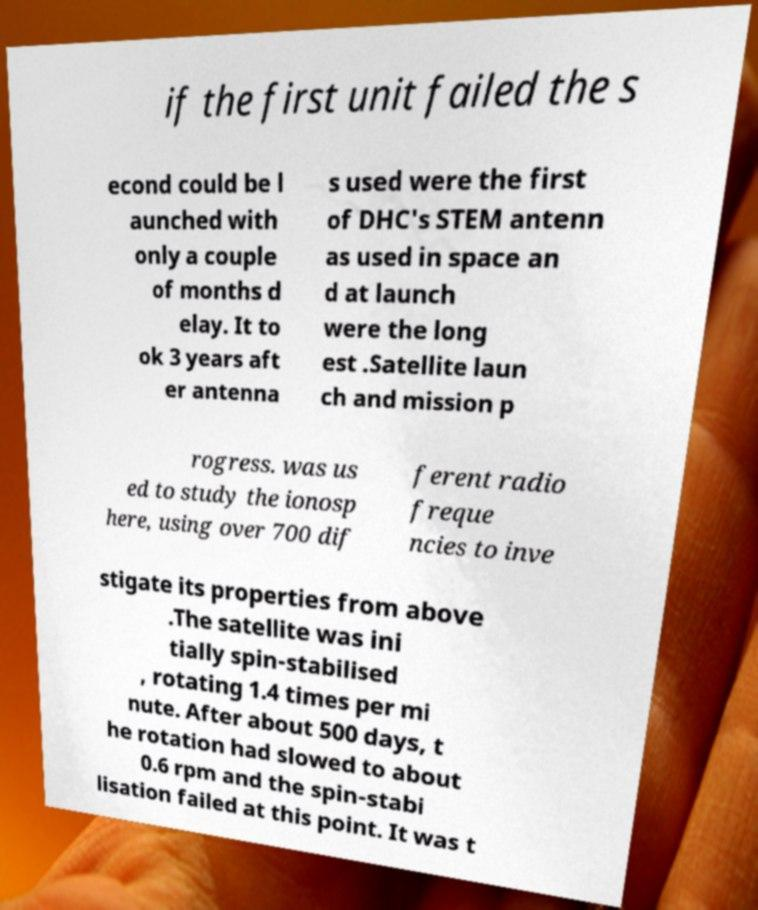I need the written content from this picture converted into text. Can you do that? if the first unit failed the s econd could be l aunched with only a couple of months d elay. It to ok 3 years aft er antenna s used were the first of DHC's STEM antenn as used in space an d at launch were the long est .Satellite laun ch and mission p rogress. was us ed to study the ionosp here, using over 700 dif ferent radio freque ncies to inve stigate its properties from above .The satellite was ini tially spin-stabilised , rotating 1.4 times per mi nute. After about 500 days, t he rotation had slowed to about 0.6 rpm and the spin-stabi lisation failed at this point. It was t 